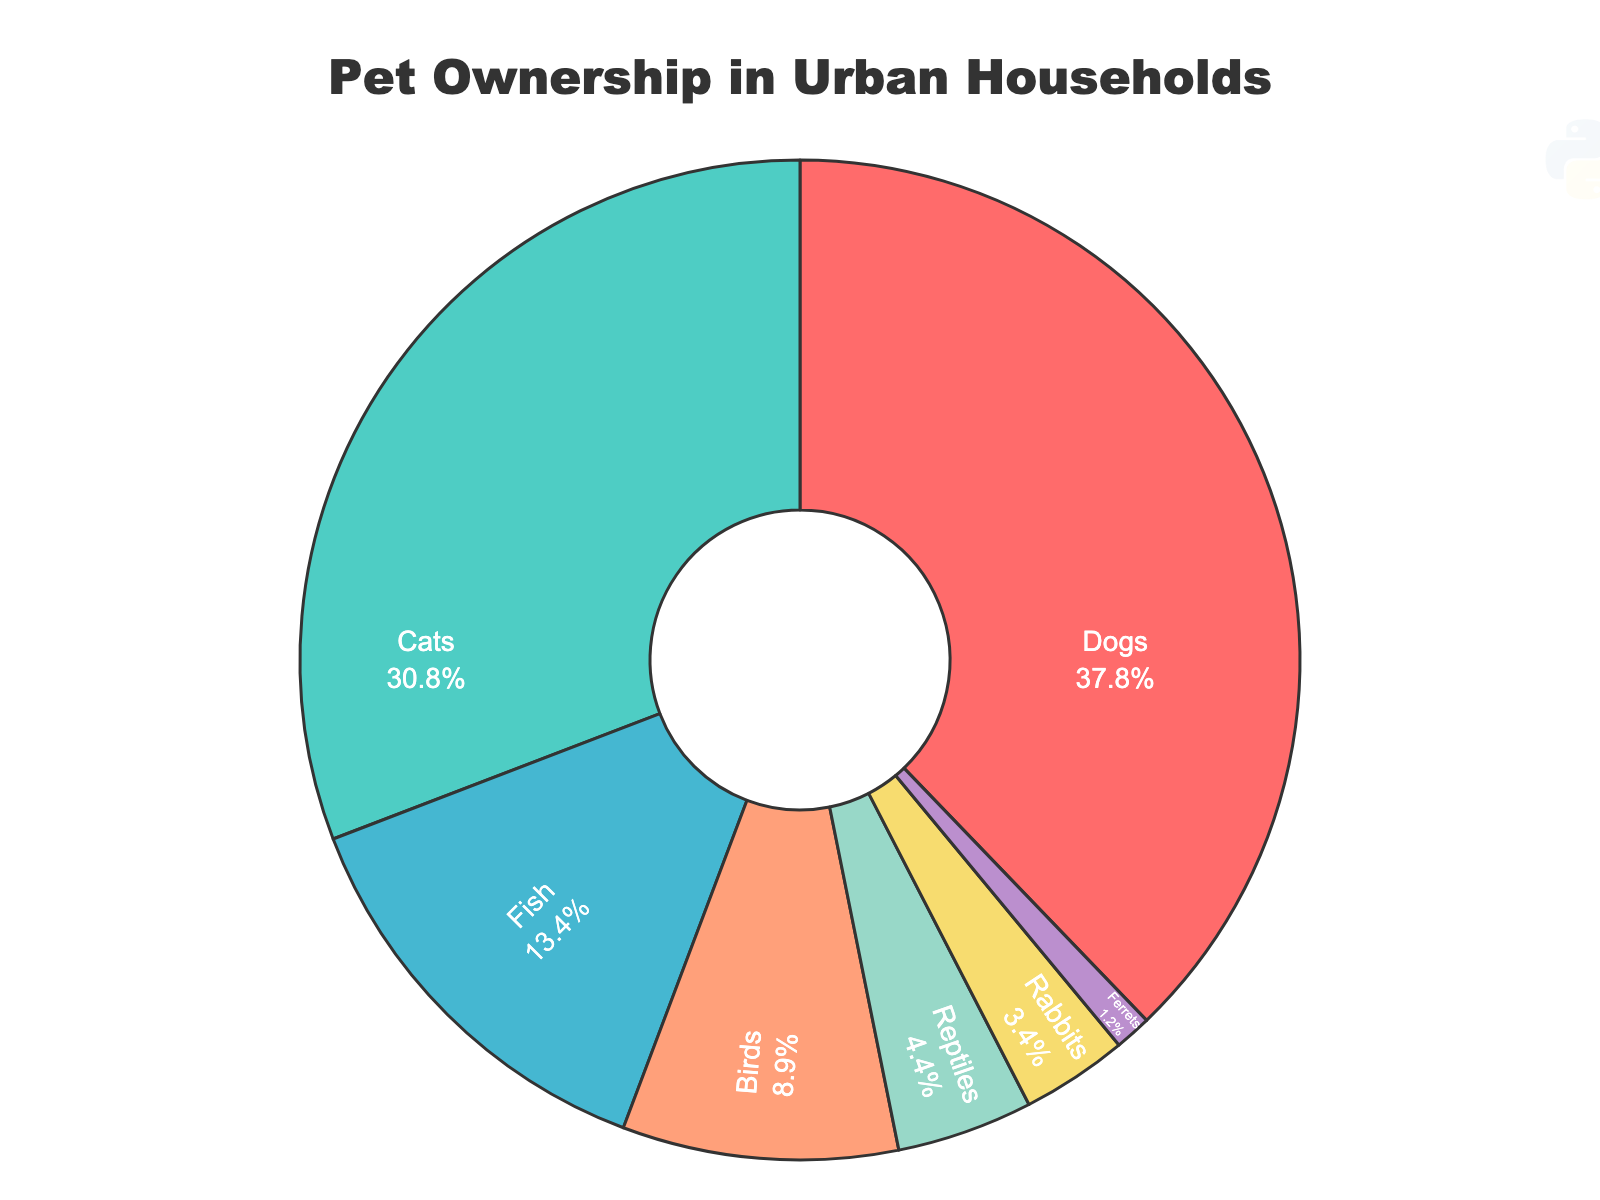What percentage of urban households own dogs? The chart indicates that the segment representing dogs shows a percentage label directly inside it.
Answer: 35.2% How many types of pets have a percentage higher than 10% in urban households? Dogs, cats, and fish are the pet types that have percentages higher than 10%.
Answer: 3 What is the combined percentage of households owning birds and reptiles? Adding the percentages for birds (8.3%) and reptiles (4.1%) gives a total of 8.3 + 4.1 = 12.4%.
Answer: 12.4% Which pet type has the smallest share of urban households? By visually examining the segments of the pie chart, ferrets have the smallest percentage.
Answer: Ferrets Is the percentage of households owning cats greater than or less than the percentage of households owning dogs? Comparing the two segments, cats have a percentage of 28.7%, while dogs have a percentage of 35.2%. Therefore, cats have a smaller percentage.
Answer: Less than Which two pet types together make up a percentage closest to 30% of urban households? Summing the percentages of rabbits (3.2%) and birds (8.3%) gives 3.2 + 8.3 = 11.5%, summing the percentages of fish (12.5%) and reptiles (4.1%) gives 12.5 + 4.1 = 16.6%. Adding the percentages of cats (28.7%) and ferrets (1.1%) gives 28.7 + 1.1 = 29.8%. 29.8% is closest to 30%.
Answer: Cats and ferrets What is the difference in percentage points between households that own fish and those that own birds? Subtracting the percentage of households that own birds (8.3%) from those that own fish (12.5%) gives 12.5 - 8.3 = 4.2 percentage points.
Answer: 4.2 What color is used to represent households owning reptiles on the pie chart? Visually identifying the segment for reptiles on the chart, it is colored in purple.
Answer: Purple If you were to combine the percentages of households owning ferrets and rabbits, would the total still be less than the percentage of households owning fish? Adding the percentages of ferrets (1.1%) and rabbits (3.2%) gives 1.1 + 3.2 = 4.3%. Comparing this with the percentage of fish (12.5%), 4.3% is indeed less than 12.5%.
Answer: Yes 